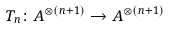<formula> <loc_0><loc_0><loc_500><loc_500>T _ { n } \colon A ^ { \otimes ( n + 1 ) } \to A ^ { \otimes ( n + 1 ) }</formula> 